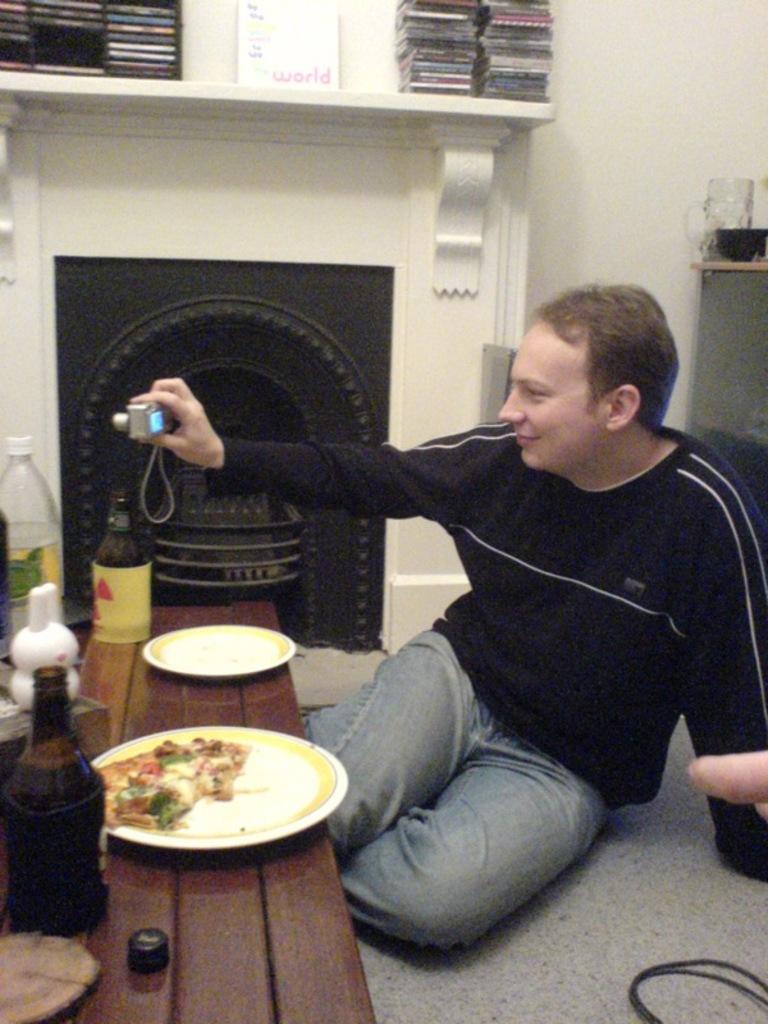What word is printed on the white box above the fireplace?
Ensure brevity in your answer.  World. 